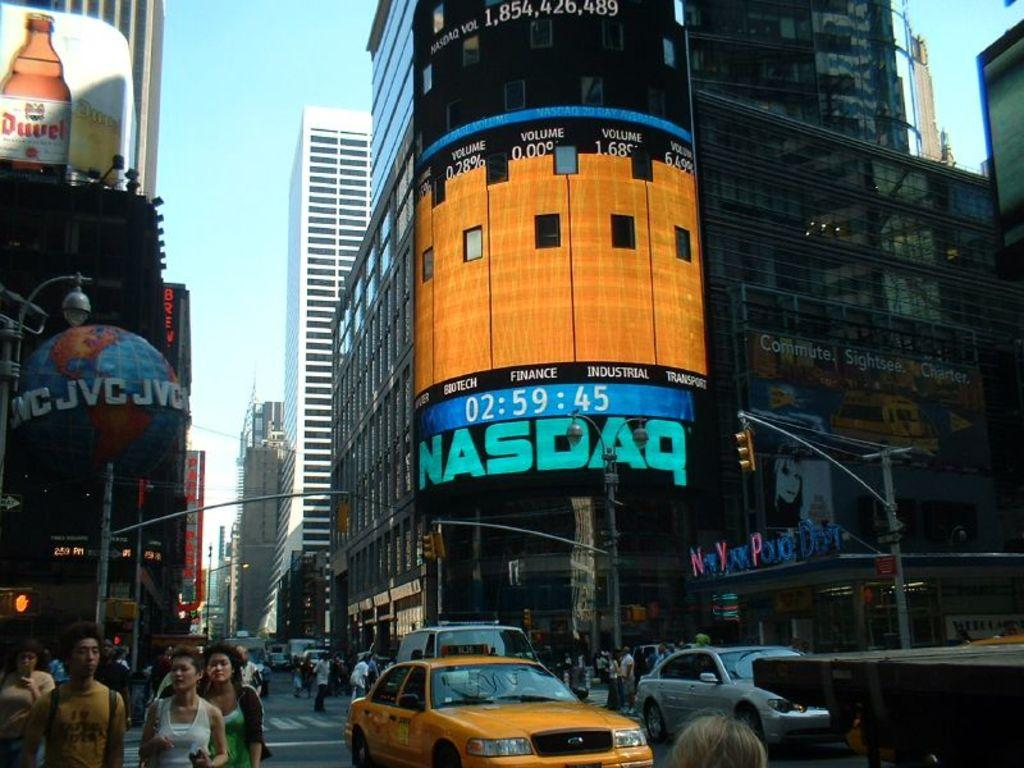Provide a one-sentence caption for the provided image. A busy intersection with a large monitor listing the NASDAQ stock ratings. 